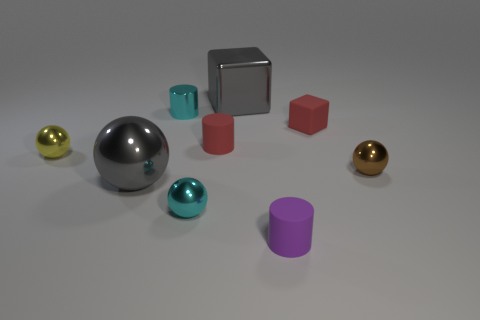Which object stands out the most to you and why? The silver sphere stands out the most because of its reflective surface and central positioning, which draws the eye amid the other colorful, less reflective objects. 